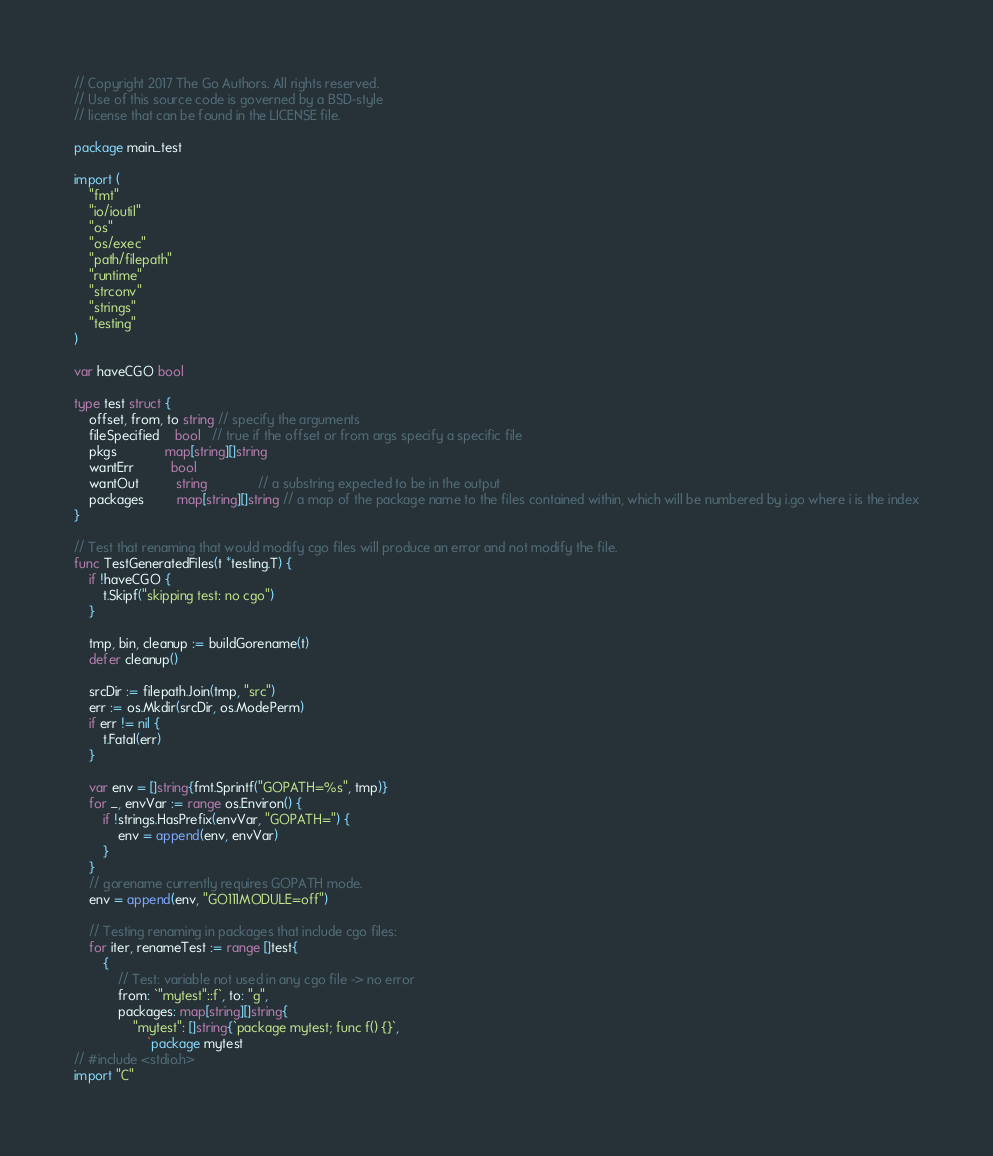<code> <loc_0><loc_0><loc_500><loc_500><_Go_>// Copyright 2017 The Go Authors. All rights reserved.
// Use of this source code is governed by a BSD-style
// license that can be found in the LICENSE file.

package main_test

import (
	"fmt"
	"io/ioutil"
	"os"
	"os/exec"
	"path/filepath"
	"runtime"
	"strconv"
	"strings"
	"testing"
)

var haveCGO bool

type test struct {
	offset, from, to string // specify the arguments
	fileSpecified    bool   // true if the offset or from args specify a specific file
	pkgs             map[string][]string
	wantErr          bool
	wantOut          string              // a substring expected to be in the output
	packages         map[string][]string // a map of the package name to the files contained within, which will be numbered by i.go where i is the index
}

// Test that renaming that would modify cgo files will produce an error and not modify the file.
func TestGeneratedFiles(t *testing.T) {
	if !haveCGO {
		t.Skipf("skipping test: no cgo")
	}

	tmp, bin, cleanup := buildGorename(t)
	defer cleanup()

	srcDir := filepath.Join(tmp, "src")
	err := os.Mkdir(srcDir, os.ModePerm)
	if err != nil {
		t.Fatal(err)
	}

	var env = []string{fmt.Sprintf("GOPATH=%s", tmp)}
	for _, envVar := range os.Environ() {
		if !strings.HasPrefix(envVar, "GOPATH=") {
			env = append(env, envVar)
		}
	}
	// gorename currently requires GOPATH mode.
	env = append(env, "GO111MODULE=off")

	// Testing renaming in packages that include cgo files:
	for iter, renameTest := range []test{
		{
			// Test: variable not used in any cgo file -> no error
			from: `"mytest"::f`, to: "g",
			packages: map[string][]string{
				"mytest": []string{`package mytest; func f() {}`,
					`package mytest
// #include <stdio.h>
import "C"
</code> 